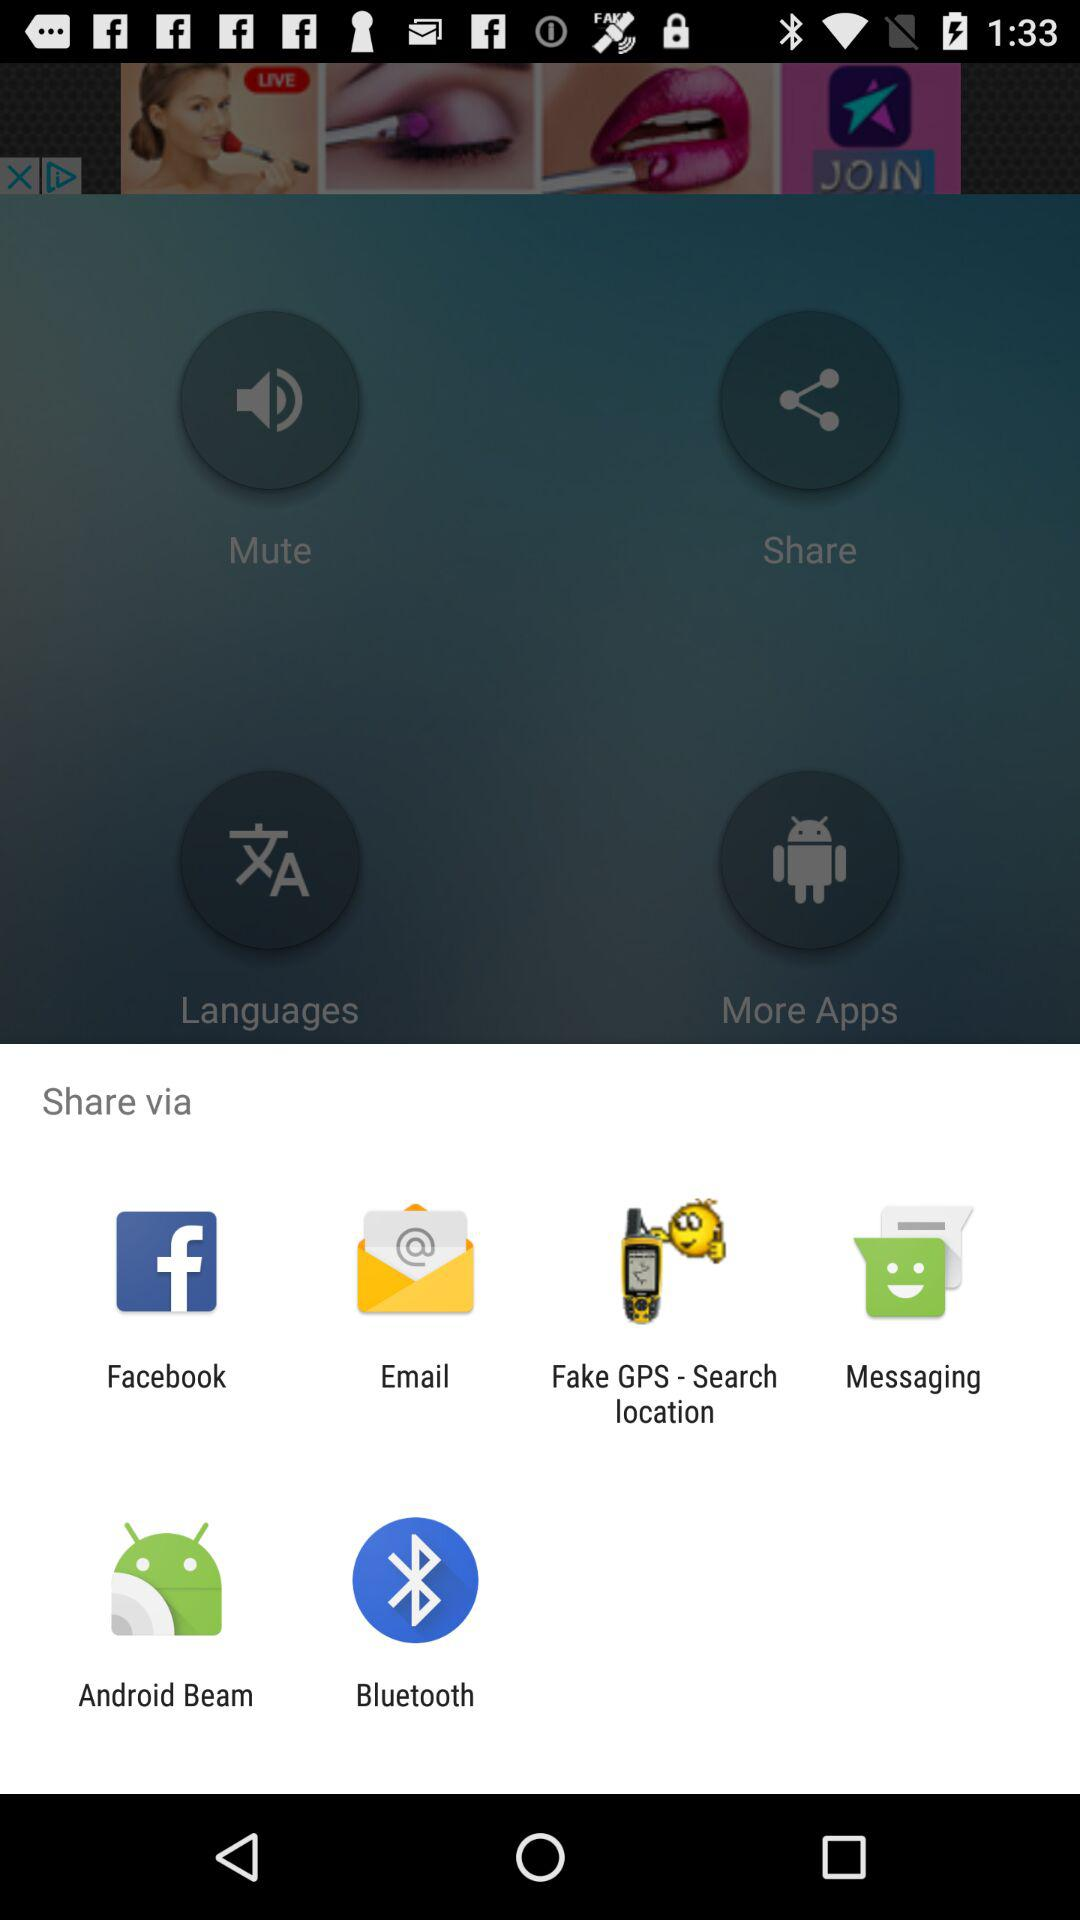What are the different options to share? The different options to share are: " Facebook", "Email", "Fake GPS - Search location", "Messaging", "Android Beam", and "Bluetooth". 